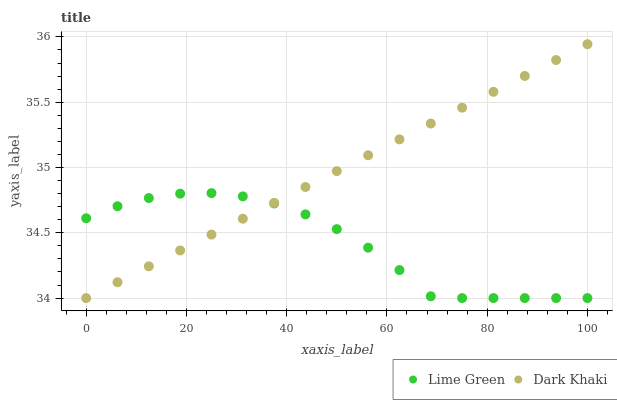Does Lime Green have the minimum area under the curve?
Answer yes or no. Yes. Does Dark Khaki have the maximum area under the curve?
Answer yes or no. Yes. Does Lime Green have the maximum area under the curve?
Answer yes or no. No. Is Dark Khaki the smoothest?
Answer yes or no. Yes. Is Lime Green the roughest?
Answer yes or no. Yes. Is Lime Green the smoothest?
Answer yes or no. No. Does Dark Khaki have the lowest value?
Answer yes or no. Yes. Does Dark Khaki have the highest value?
Answer yes or no. Yes. Does Lime Green have the highest value?
Answer yes or no. No. Does Dark Khaki intersect Lime Green?
Answer yes or no. Yes. Is Dark Khaki less than Lime Green?
Answer yes or no. No. Is Dark Khaki greater than Lime Green?
Answer yes or no. No. 